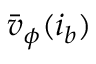<formula> <loc_0><loc_0><loc_500><loc_500>\bar { v } _ { \phi } ( i _ { b } )</formula> 